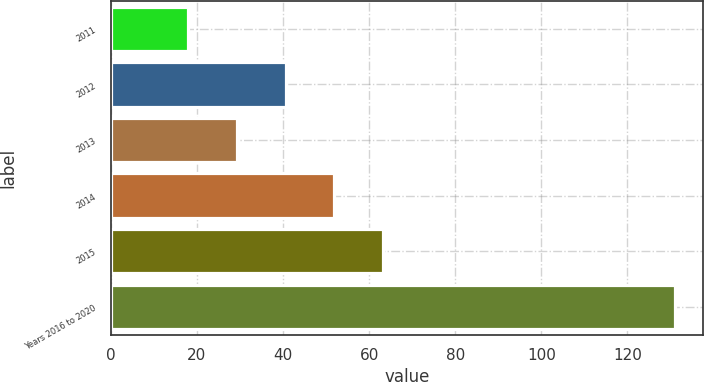Convert chart. <chart><loc_0><loc_0><loc_500><loc_500><bar_chart><fcel>2011<fcel>2012<fcel>2013<fcel>2014<fcel>2015<fcel>Years 2016 to 2020<nl><fcel>18<fcel>40.6<fcel>29.3<fcel>51.9<fcel>63.2<fcel>131<nl></chart> 